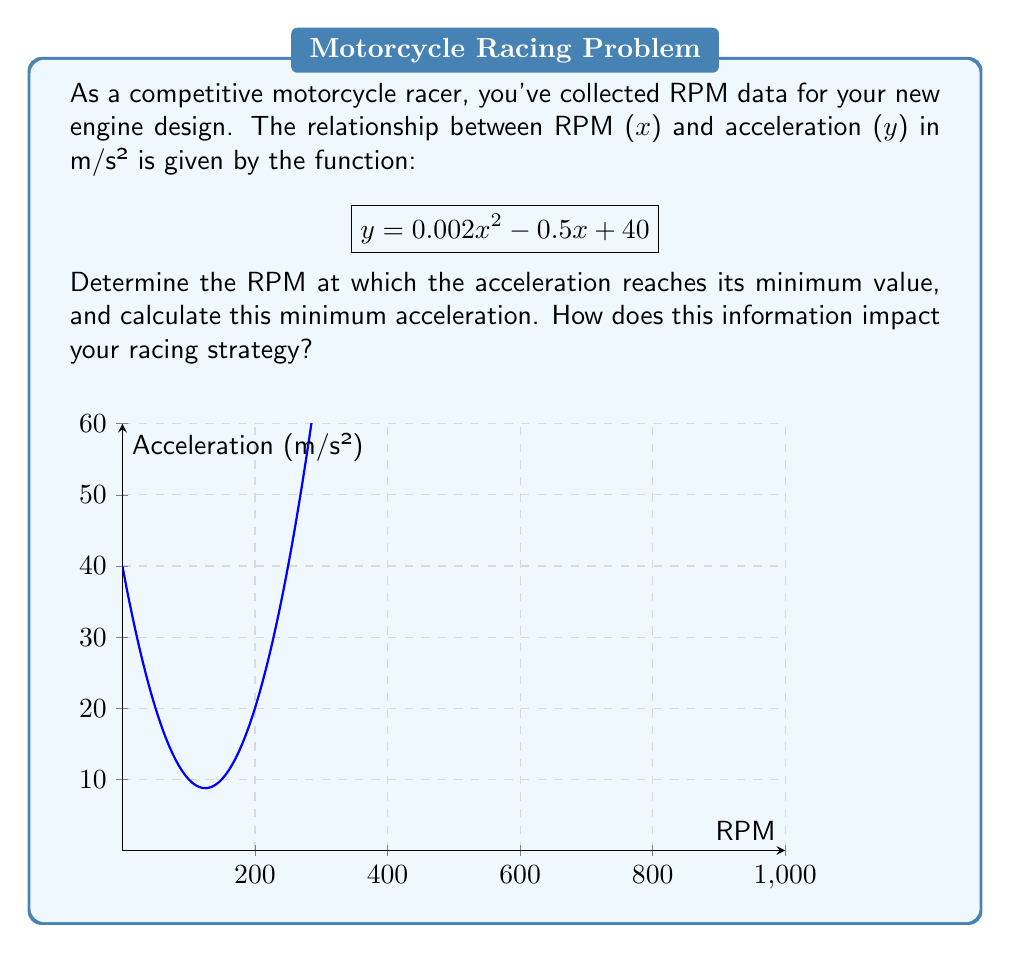Help me with this question. To solve this problem, we need to follow these steps:

1) The function given is a quadratic function in the form:
   $$y = ax^2 + bx + c$$
   where $a = 0.002$, $b = -0.5$, and $c = 40$

2) For a quadratic function, the x-coordinate of the vertex represents the point where the function reaches its minimum (if $a > 0$) or maximum (if $a < 0$) value.

3) The formula for the x-coordinate of the vertex is:
   $$x = -\frac{b}{2a}$$

4) Substituting our values:
   $$x = -\frac{-0.5}{2(0.002)} = \frac{0.5}{0.004} = 125$$

5) This means the acceleration reaches its minimum value at 125 RPM.

6) To find the minimum acceleration, we substitute this x-value back into our original function:

   $$y = 0.002(125)^2 - 0.5(125) + 40$$
   $$y = 0.002(15625) - 62.5 + 40$$
   $$y = 31.25 - 62.5 + 40 = 8.75$$

7) Therefore, the minimum acceleration is 8.75 m/s².

This information impacts racing strategy by indicating that the engine provides the least acceleration at 125 RPM. A racer would want to avoid operating at this RPM to maintain higher acceleration. Instead, they should aim to keep the engine RPM either below or above this point, depending on the specific characteristics of the track and race conditions.
Answer: Minimum at 125 RPM; 8.75 m/s² 